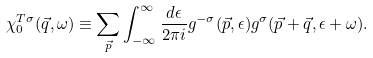Convert formula to latex. <formula><loc_0><loc_0><loc_500><loc_500>\chi _ { 0 } ^ { T \sigma } ( \vec { q } , \omega ) \equiv \sum _ { \vec { p } } \int _ { - \infty } ^ { \infty } \frac { d \epsilon } { 2 \pi i } g ^ { - \sigma } ( \vec { p } , \epsilon ) g ^ { \sigma } ( \vec { p } + \vec { q } , \epsilon + \omega ) .</formula> 